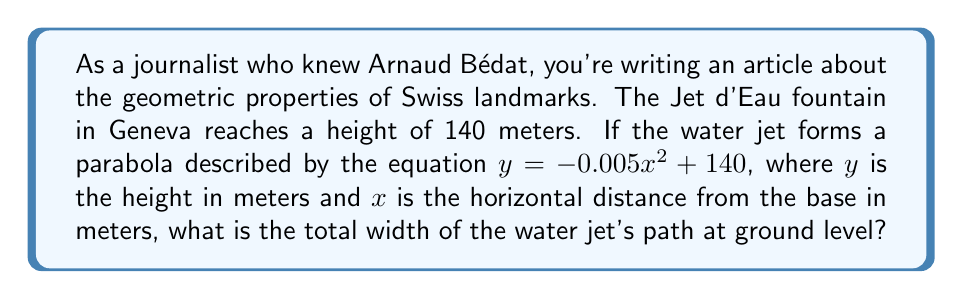Give your solution to this math problem. Let's approach this step-by-step:

1) The parabola is described by the equation $y = -0.005x^2 + 140$

2) To find the width at ground level, we need to find the x-intercepts of this parabola. At ground level, $y = 0$

3) Substituting $y = 0$ into the equation:
   $0 = -0.005x^2 + 140$

4) Rearranging the equation:
   $0.005x^2 = 140$
   $x^2 = 140 / 0.005 = 28000$

5) Taking the square root of both sides:
   $x = \pm \sqrt{28000} = \pm 167.33$ meters

6) This means the water jet reaches 167.33 meters to the left and right of the central point.

7) The total width is twice this distance:
   Total width $= 2 * 167.33 = 334.66$ meters

[asy]
import graph;
size(200,200);
real f(real x) {return -0.005*x^2 + 140;}
draw(graph(f,-167.33,167.33));
draw((-170,0)--(170,0),arrow=Arrow(TeXHead));
draw((0,-10)--(0,150),arrow=Arrow(TeXHead));
label("x",(170,0),E);
label("y",(0,150),N);
dot((-167.33,0));
dot((167.33,0));
label("334.66 m",(-167.33,-5)--(167.33,-5),S);
[/asy]
Answer: 334.66 meters 